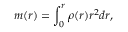Convert formula to latex. <formula><loc_0><loc_0><loc_500><loc_500>m ( r ) = \int _ { 0 } ^ { r } \rho ( r ) r ^ { 2 } d r ,</formula> 